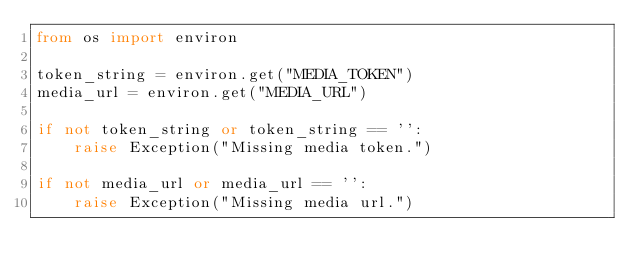<code> <loc_0><loc_0><loc_500><loc_500><_Python_>from os import environ

token_string = environ.get("MEDIA_TOKEN")
media_url = environ.get("MEDIA_URL")

if not token_string or token_string == '':
    raise Exception("Missing media token.")

if not media_url or media_url == '':
    raise Exception("Missing media url.")
</code> 